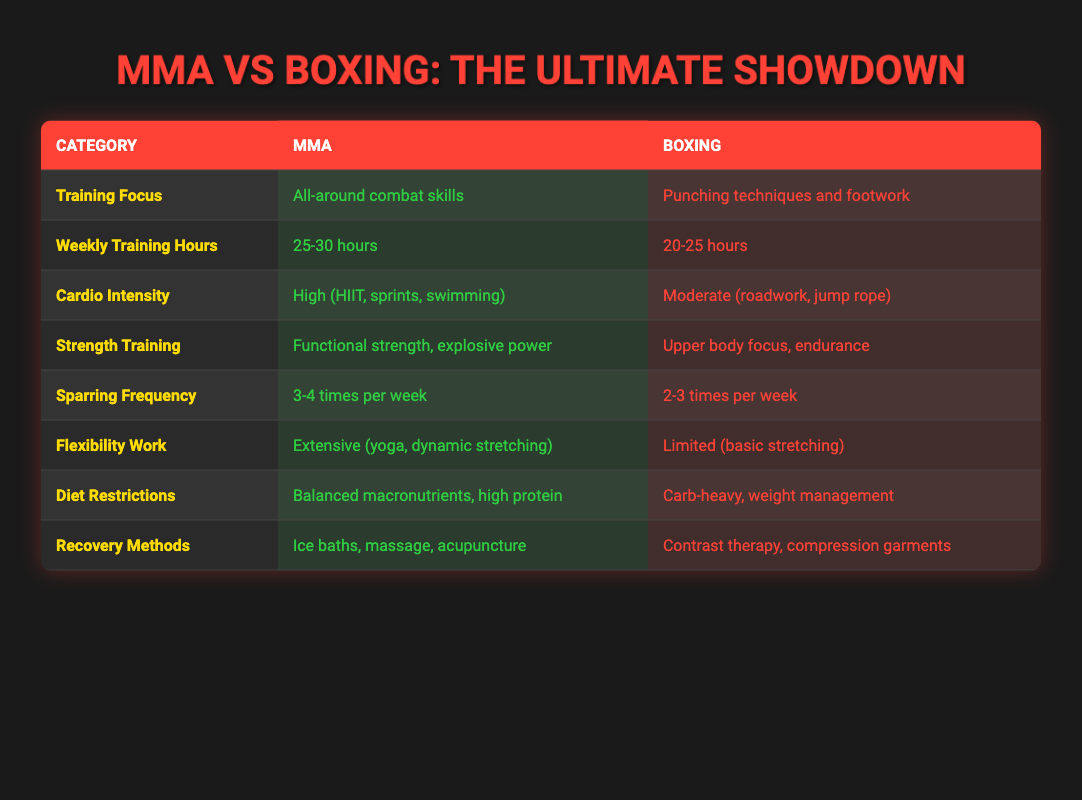What is the training focus of MMA? The table shows in the "Training Focus" row that MMA has an all-around combat skills focus, while boxing focuses on punching techniques and footwork. Hence, for MMA, the answer is "All-around combat skills."
Answer: All-around combat skills How many weekly training hours do boxers typically train? Referring to the "Weekly Training Hours" row, boxing has a range of 20-25 hours listed compared to MMA's 25-30 hours. Therefore, the answer is 20-25 hours.
Answer: 20-25 hours Which sport has a higher sparring frequency? By comparing the "Sparring Frequency" row, MMA is indicated to spar 3-4 times per week, whereas boxing spars 2-3 times per week. Thus, MMA has a higher sparring frequency.
Answer: MMA What is the average cardio intensity for both MMA and boxing training? Reading the "Cardio Intensity" row, MMA's intensity is high with HIIT, sprints, and swimming, while boxing is moderate with roadwork and jump rope. For comparison, MMA's cardio intensity is "High" and boxing's is "Moderate." Therefore, the average intensity is high for MMA and moderate for boxing.
Answer: High for MMA, Moderate for Boxing Does MMA have a comprehensive recovery approach? The "Recovery Methods" row indicates both MMA and boxing have differing approaches, with MMA utilizing ice baths, massage, and acupuncture, while boxing employs contrast therapy and compression garments. Since MMA has additional methods listed, the answer is yes.
Answer: Yes How many more hours per week do MMA fighters train compared to boxers at their respective maximum training levels? The maximum training hours for MMA is 30, while for boxing, it is 25. Subtracting boxing's maximum from MMA's maximum (30 - 25), we find that MMA fighters train 5 more hours per week at maximum capacity.
Answer: 5 hours Is there any flexibility work included in boxing training? From the "Flexibility Work" row, MMA indicates extensive work, whereas boxing is limited to basic stretching. Since boxing does have some flexibility work, the answer is yes.
Answer: Yes Which training regimen has a greater focus on functional strength? In the "Strength Training" row, MMA focuses on functional strength and explosive power, while boxing is centered on upper body endurance. Therefore, MMA has a greater focus on functional strength.
Answer: MMA How many times a week do boxers typically engage in sparring compared to MMA fighters? Reviewing the "Sparring Frequency" row, boxers spar 2-3 times per week, whereas MMA fighters spar 3-4 times per week. Thus, MMA fighters typically engage in sparring more often than boxers.
Answer: More often in MMA 